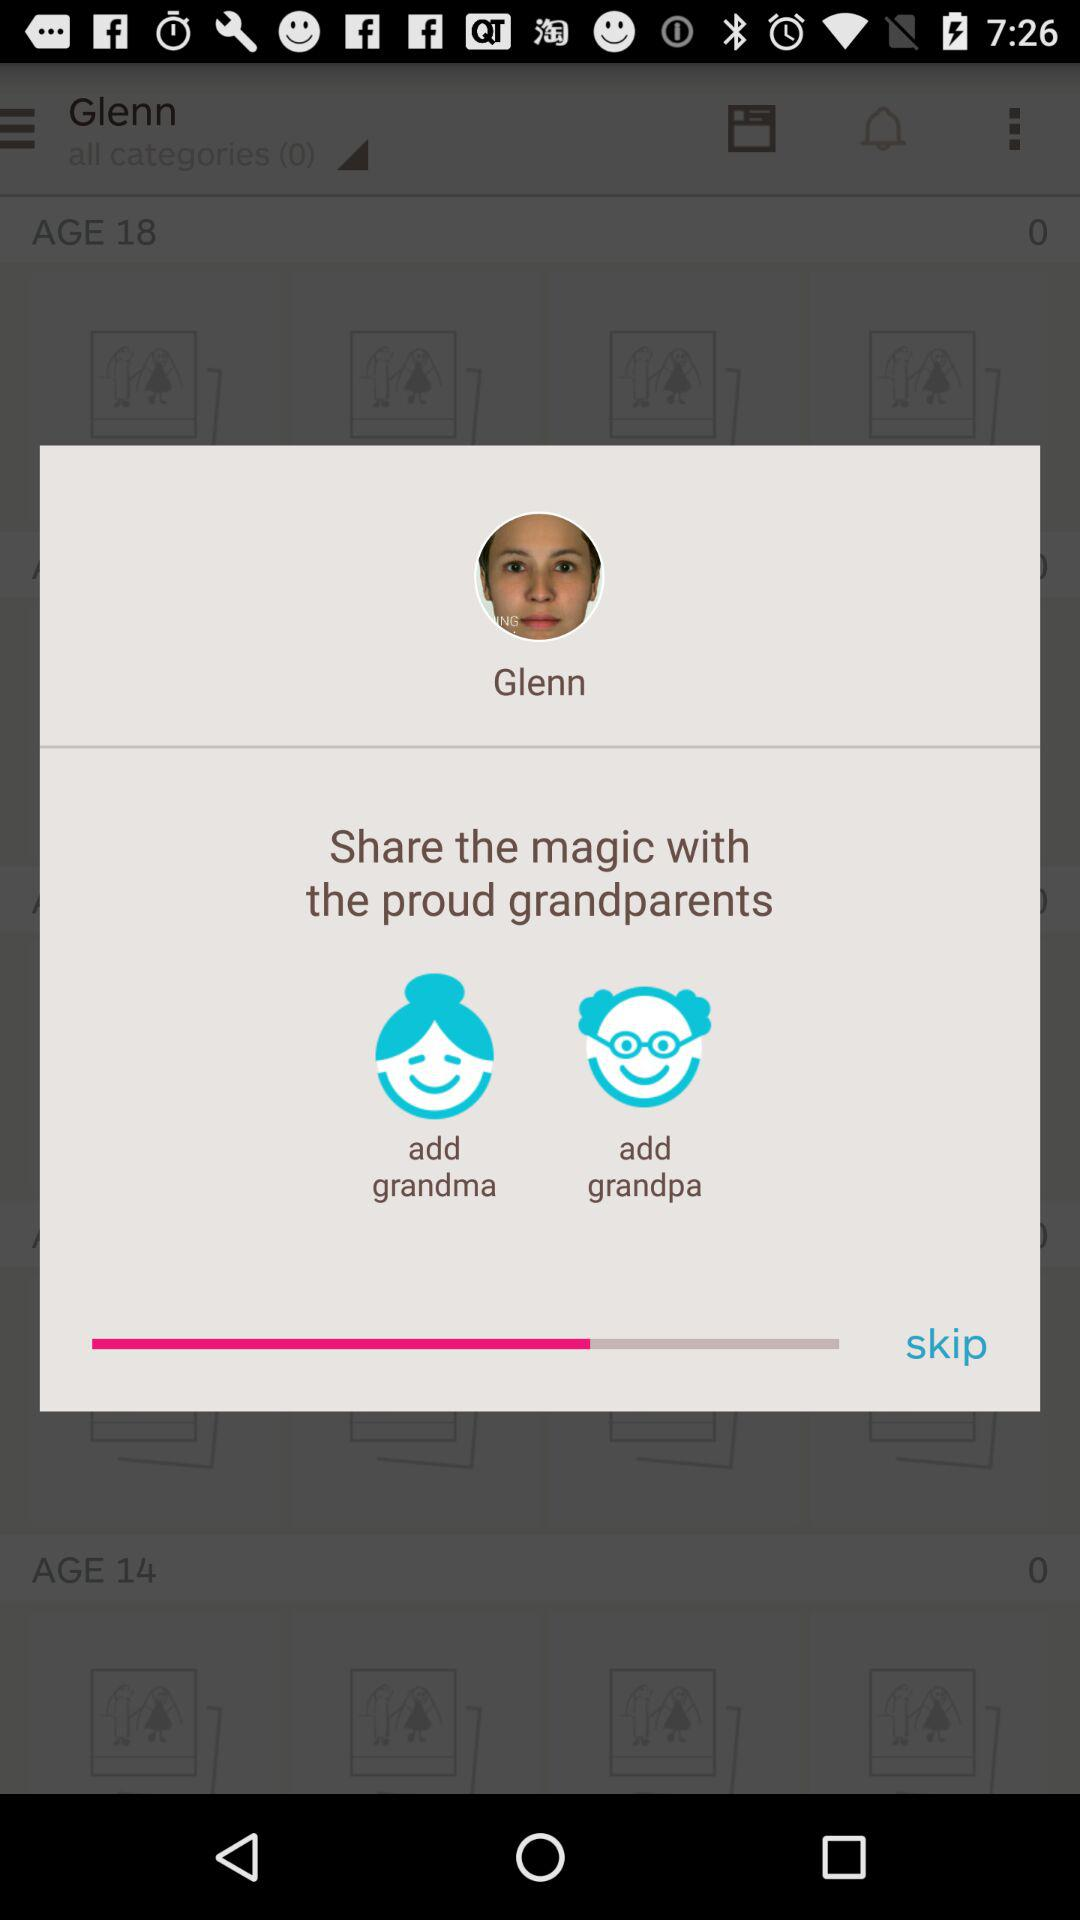Is a grandma or grandpa added?
When the provided information is insufficient, respond with <no answer>. <no answer> 